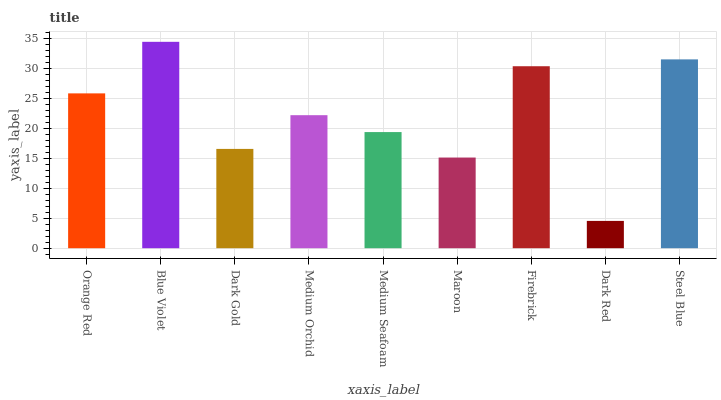Is Dark Red the minimum?
Answer yes or no. Yes. Is Blue Violet the maximum?
Answer yes or no. Yes. Is Dark Gold the minimum?
Answer yes or no. No. Is Dark Gold the maximum?
Answer yes or no. No. Is Blue Violet greater than Dark Gold?
Answer yes or no. Yes. Is Dark Gold less than Blue Violet?
Answer yes or no. Yes. Is Dark Gold greater than Blue Violet?
Answer yes or no. No. Is Blue Violet less than Dark Gold?
Answer yes or no. No. Is Medium Orchid the high median?
Answer yes or no. Yes. Is Medium Orchid the low median?
Answer yes or no. Yes. Is Orange Red the high median?
Answer yes or no. No. Is Blue Violet the low median?
Answer yes or no. No. 